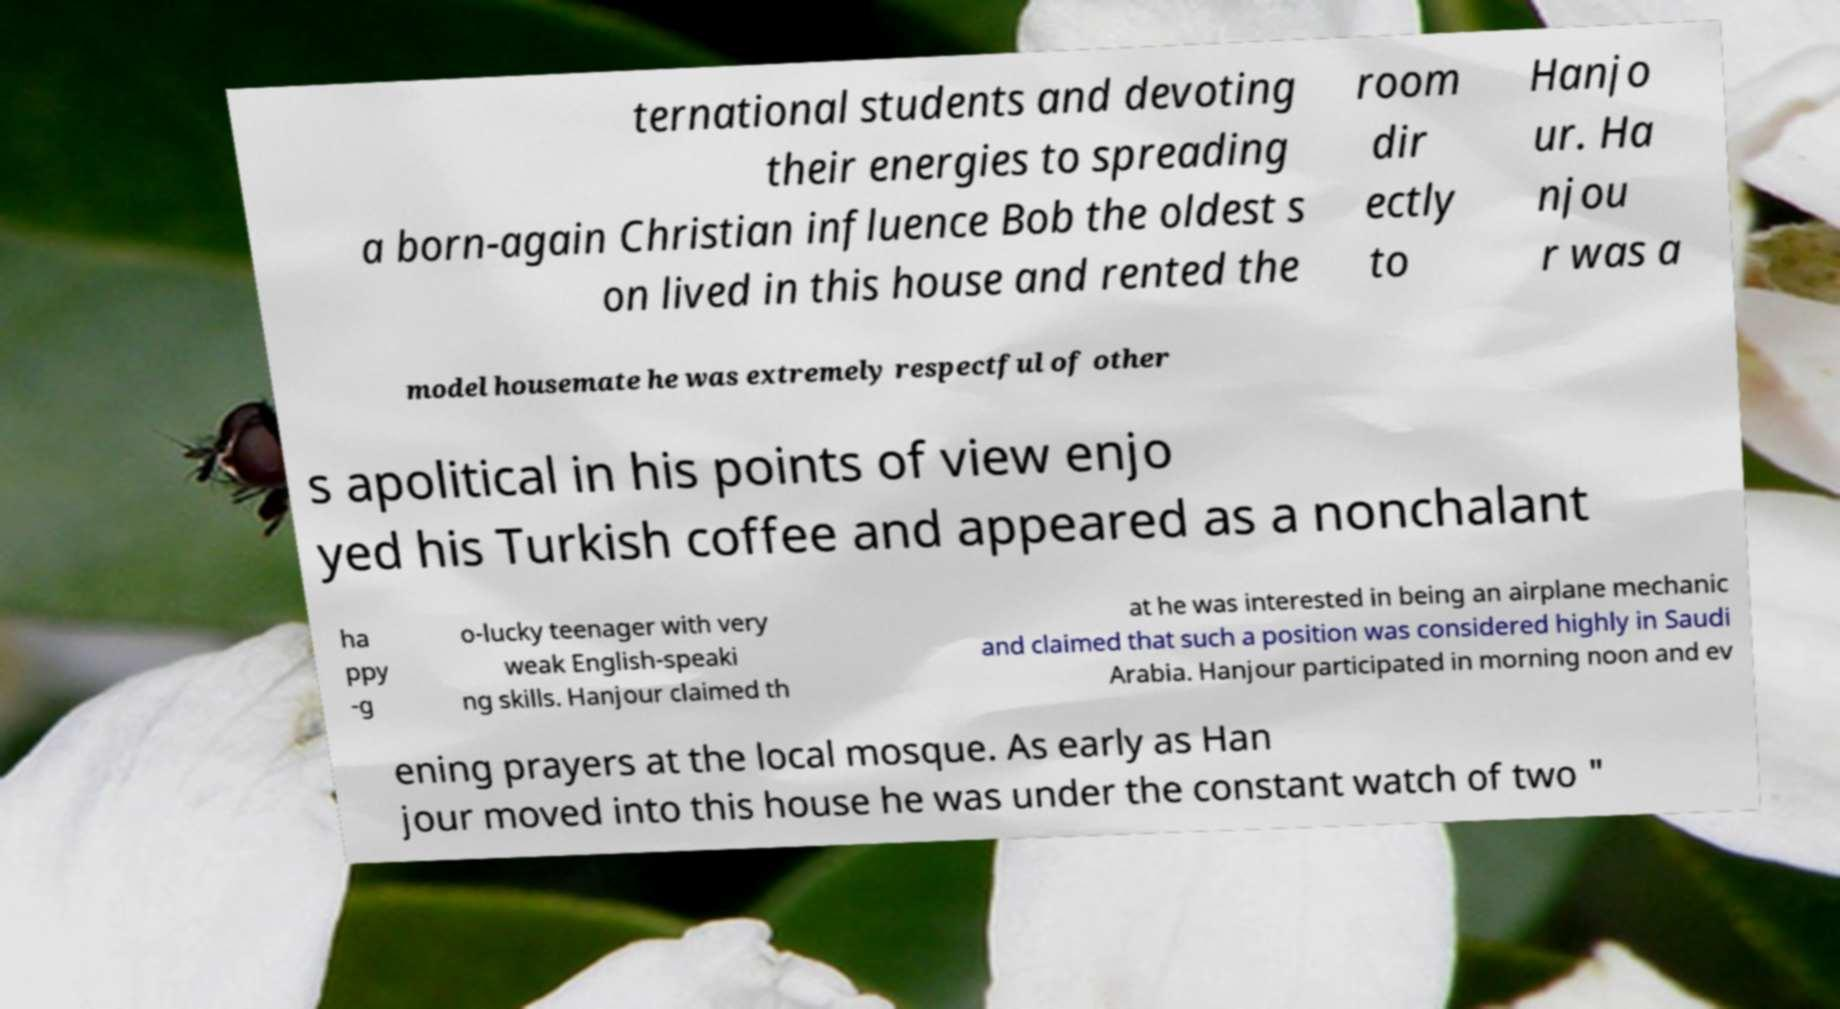Please identify and transcribe the text found in this image. ternational students and devoting their energies to spreading a born-again Christian influence Bob the oldest s on lived in this house and rented the room dir ectly to Hanjo ur. Ha njou r was a model housemate he was extremely respectful of other s apolitical in his points of view enjo yed his Turkish coffee and appeared as a nonchalant ha ppy -g o-lucky teenager with very weak English-speaki ng skills. Hanjour claimed th at he was interested in being an airplane mechanic and claimed that such a position was considered highly in Saudi Arabia. Hanjour participated in morning noon and ev ening prayers at the local mosque. As early as Han jour moved into this house he was under the constant watch of two " 